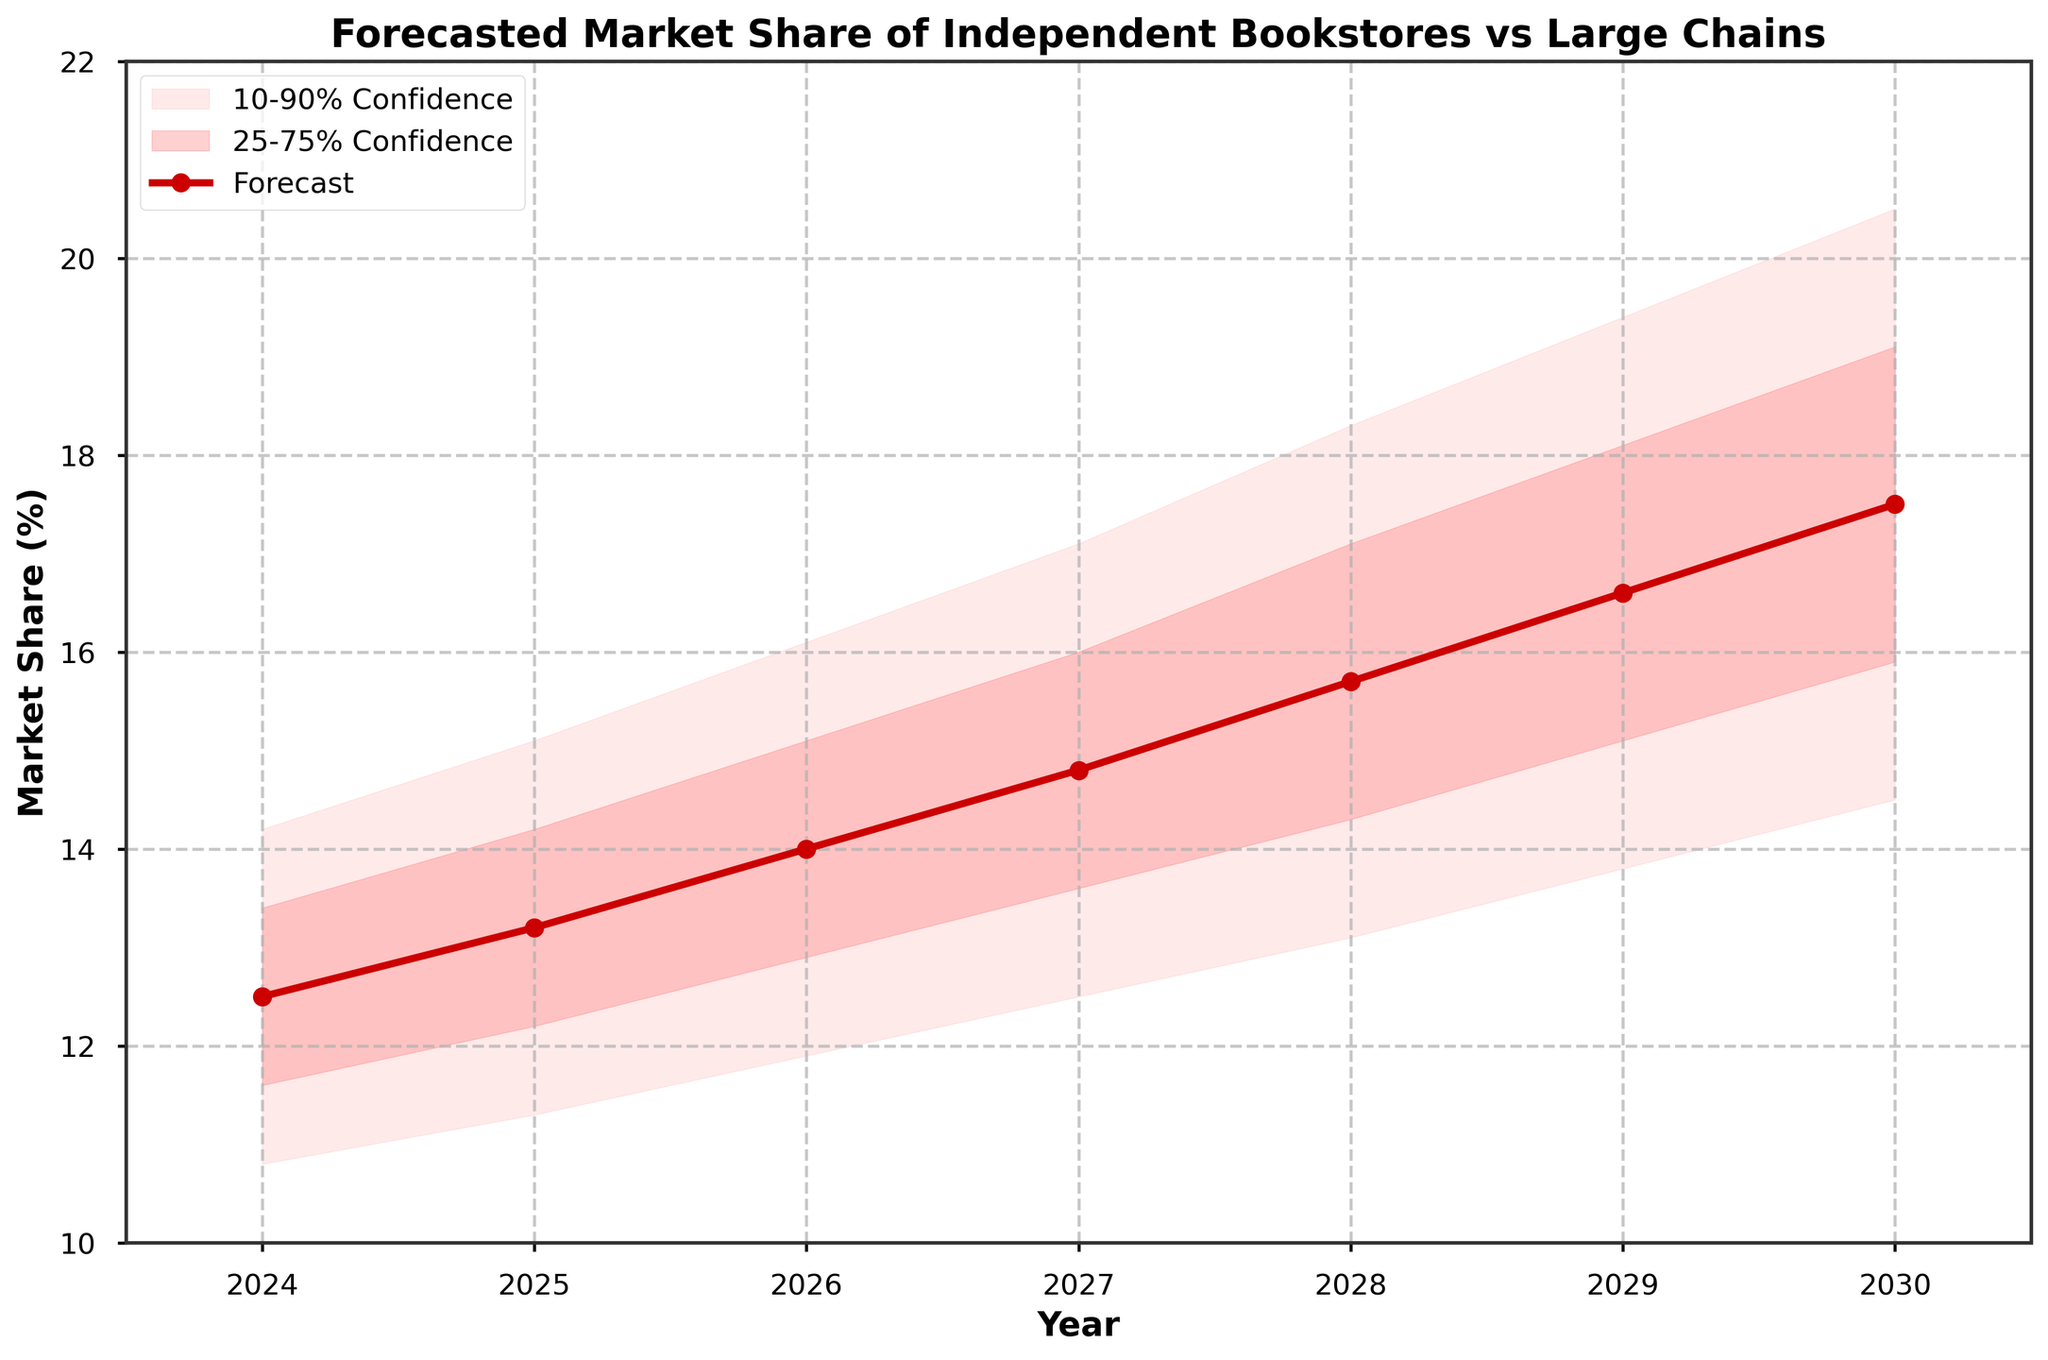What is the forecasted market share for independent bookstores in 2027? According to the plot, the forecasted market share for independent bookstores in 2027 is shown by the red line and marker on the graph. The value is labeled directly.
Answer: 14.8% What is the title of the figure? The title of the figure is displayed at the top of the chart in bold.
Answer: Forecasted Market Share of Independent Bookstores vs Large Chains Which year shows the highest forecasted market share? By examining the peak of the red line representing the forecast, the year with the highest value can be identified. This is the rightmost point on the plot.
Answer: 2030 What is the 25-75% confidence interval for 2029? On the plot, the 25-75% confidence interval is represented by the darker shaded area. The boundaries of this interval for 2029 are given.
Answer: 15.1% to 18.1% What is the difference between the upper 90% and lower 10% bounds in 2025? To find the difference, subtract the lower 10% bound from the upper 90% bound for the year 2025. The numerical values can be directly read from the plot or data.
Answer: 3.8% How does the market share forecast for 2028 compare to 2026? By comparing the forecast values for 2028 and 2026, shown by the red line, we can observe whether the value has increased, decreased, or stayed the same.
Answer: Increased What is the average forecasted market share from 2024 to 2026? Add the forecast values for the years 2024, 2025, and 2026, then divide by the number of years (3) to find the average.
Answer: 13.23% Which year has the widest 10-90% confidence interval? Compare the widths of the lightest shaded areas (10-90% confidence intervals) for each year to see which one is the widest.
Answer: 2030 What are the x-axis and y-axis labels? The labels are found on the x-axis and y-axis of the plot, describing the data and units involved.
Answer: Year and Market Share (%) Does the market share forecast consistently increase every year? By analyzing the trend of the red line from 2024 to 2030, we can determine if there is a consistent yearly increase.
Answer: Yes 